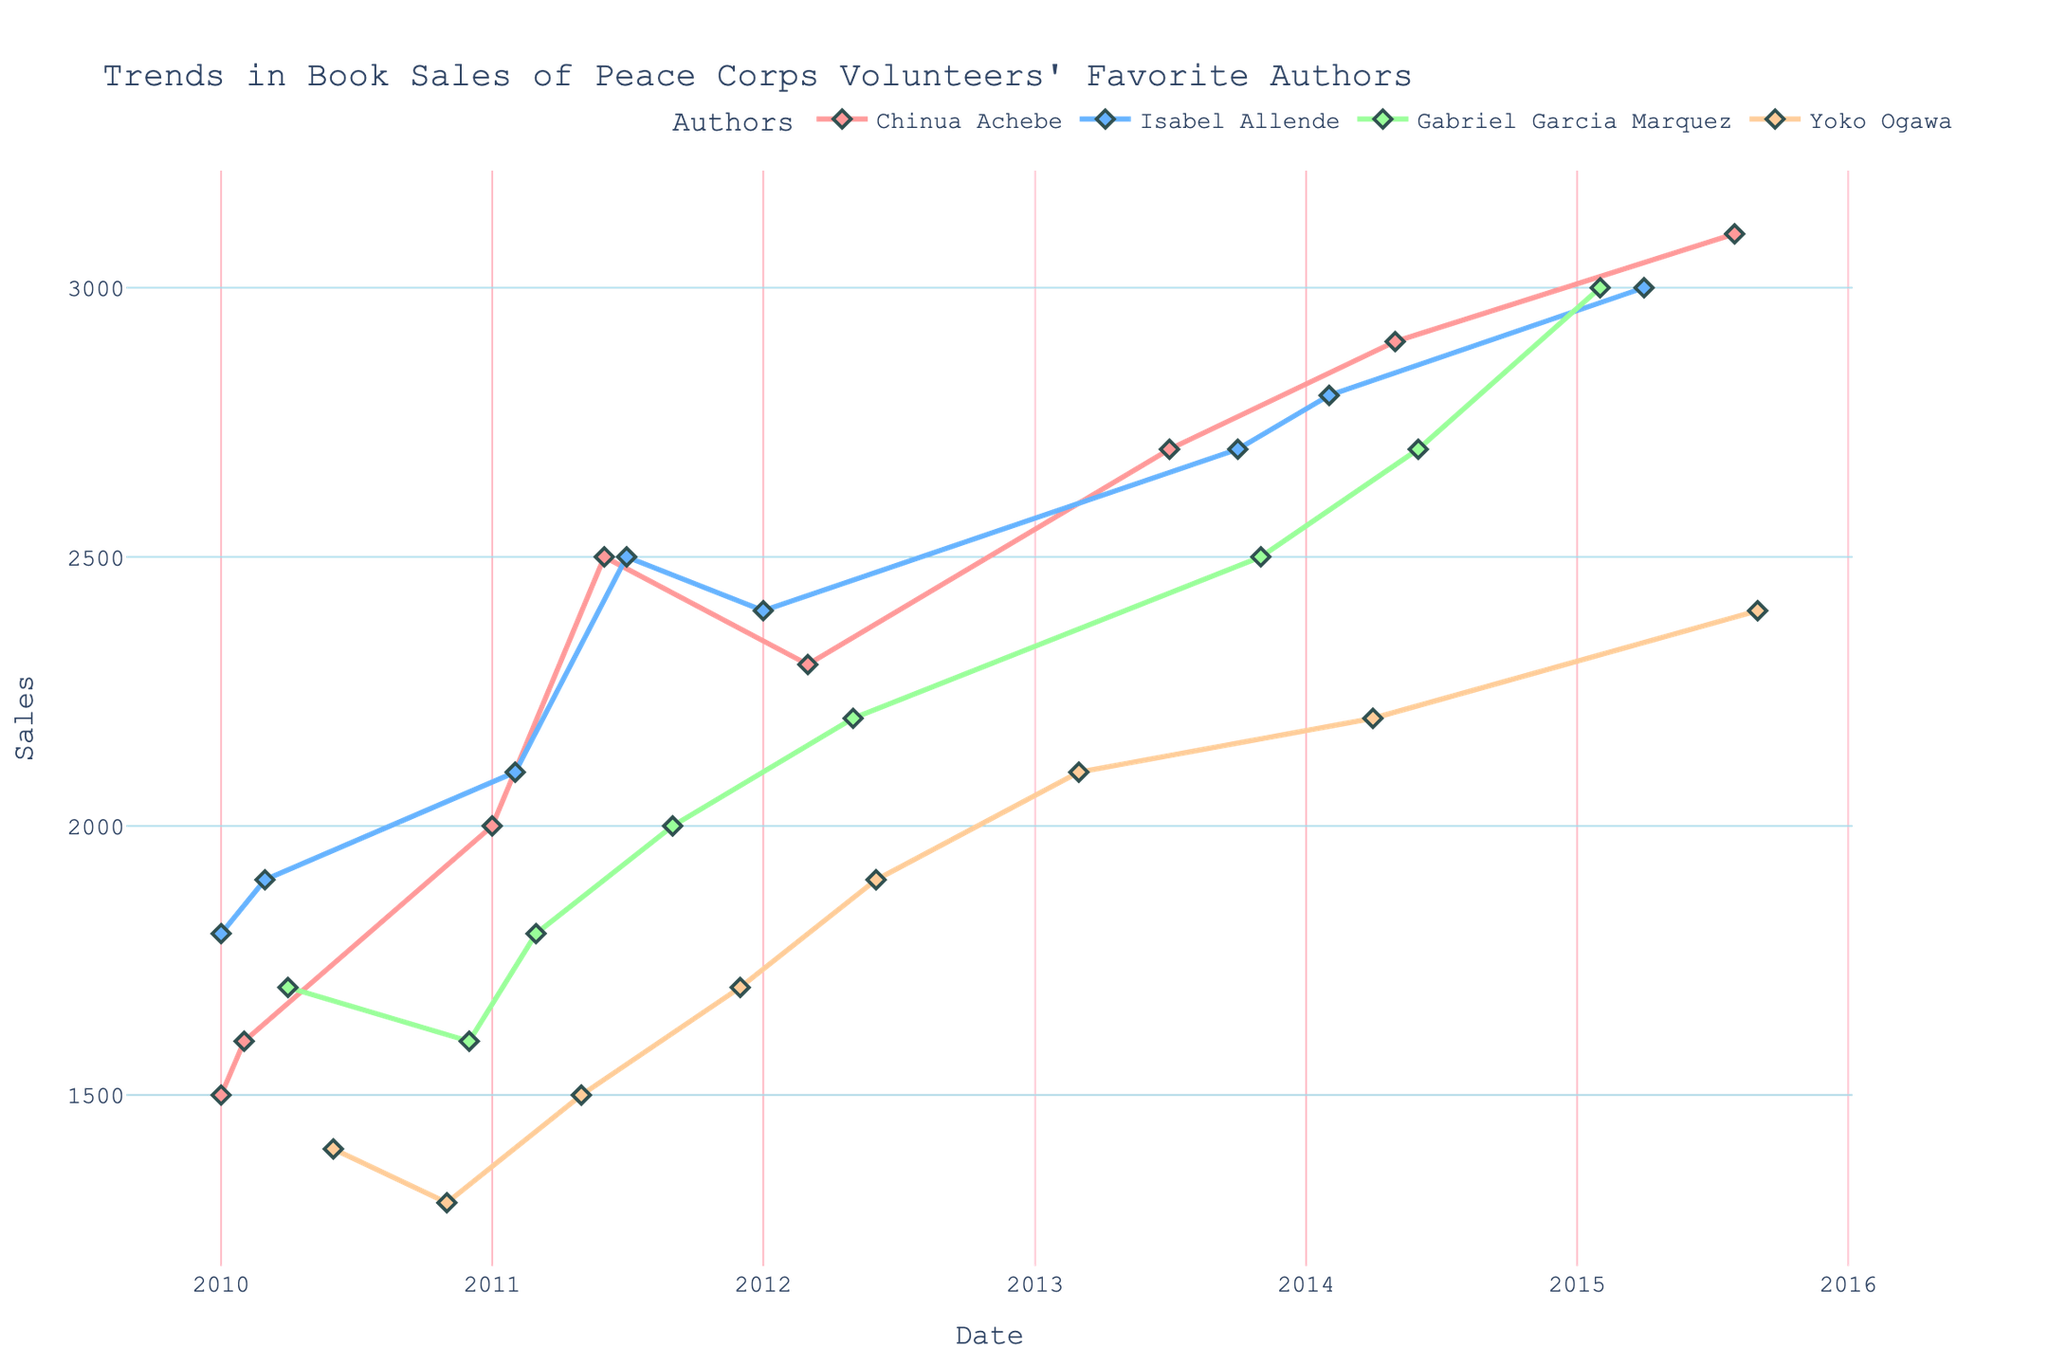what is the title of the plot? The title is located at the top of the figure. It provides a summary of what the plot represents. The title is "Trends in Book Sales of Peace Corps Volunteers' Favorite Authors."
Answer: Trends in Book Sales of Peace Corps Volunteers' Favorite Authors how many authors are represented in the plot? The legend in the plot lists the names of all the authors. There are four authors shown in the legend.
Answer: 4 which author has the highest sales recorded in the period shown? Looking at all the lines in the plot, the highest sales point is for Chinua Achebe in 2015-08 with 3100 units sold.
Answer: Chinua Achebe what is the sales trend for Isabel Allende from 2010 to 2015? Analyzing the line for Isabel Allende, it starts at 1800 in 2010-01 and generally increases over time, reaching 3000 by 2015-04.
Answer: Increasing in which year did Gabriel Garcia Marquez record a noticeable sales increase? By tracing the line for Gabriel Garcia Marquez, there is a noticeable increase between 2013 and 2015, with significant growth starts around 2013-11.
Answer: 2013 compare the sales of Yoko Ogawa in 2012-06 and 2015-09. which one is higher and by how much? Yoko Ogawa's sales in 2012-06 are 1900, and in 2015-09, they are 2400. The difference is 2400 - 1900 = 500.
Answer: 2015-09, 500 what is the combined sales total for all authors in 2014? Summing the sales for each author in 2014: Chinua Achebe (2900), Isabel Allende (2800), Gabriel Garcia Marquez (2700), and Yoko Ogawa (2200) gives a total of 2900 + 2800 + 2700 + 2200 = 10600.
Answer: 10600 which author shows the most consistent growth throughout the period? By observing the slope and consistency of the lines, Chinua Achebe shows a mostly consistent upward trend without large fluctuations.
Answer: Chinua Achebe how does the sales variability of Yoko Ogawa compare to Gabriel Garcia Marquez? Gabriel Garcia Marquez shows some variability with points varying more significantly, such as the dip in 2010-12. Yoko Ogawa also shows variability but less dramatically compared to Gabriel Garcia Marquez.
Answer: Gabriel Garcia Marquez has more variability do any authors have periods with no data points shown? Examining the lines, Chinua Achebe has no data points between 2011-06 and 2012-03, indicating a gap in the data timeline.
Answer: Yes 